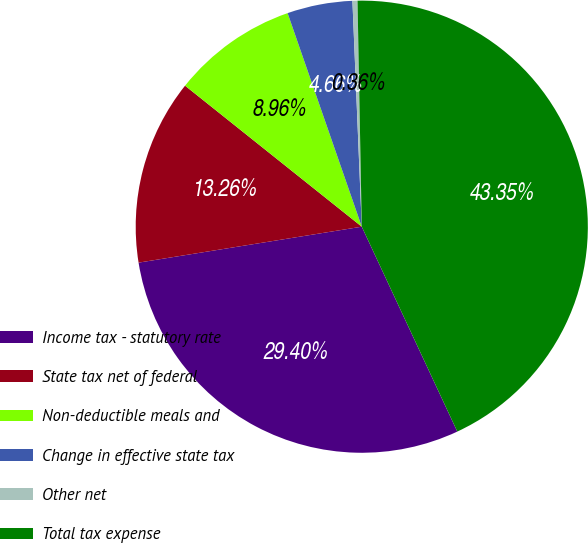Convert chart. <chart><loc_0><loc_0><loc_500><loc_500><pie_chart><fcel>Income tax - statutory rate<fcel>State tax net of federal<fcel>Non-deductible meals and<fcel>Change in effective state tax<fcel>Other net<fcel>Total tax expense<nl><fcel>29.4%<fcel>13.26%<fcel>8.96%<fcel>4.66%<fcel>0.36%<fcel>43.35%<nl></chart> 